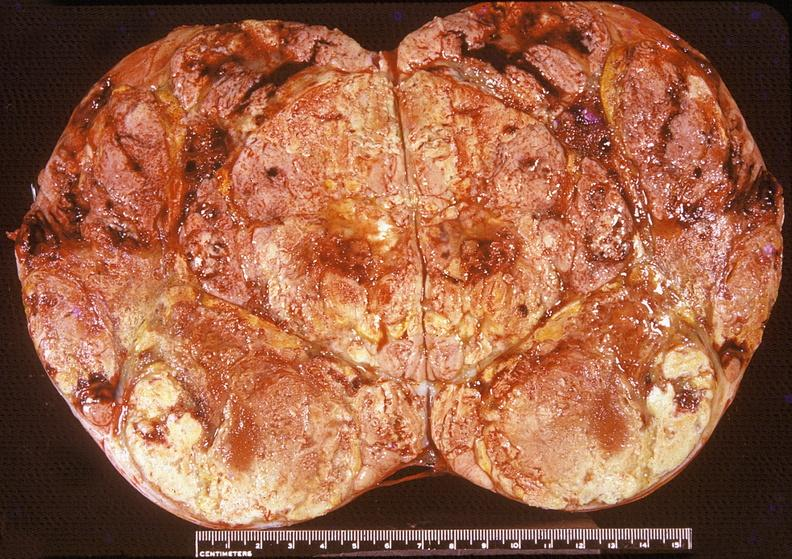does intraductal papillomatosis show adrenal, cortical carcimoma?
Answer the question using a single word or phrase. No 